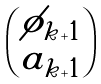<formula> <loc_0><loc_0><loc_500><loc_500>\begin{pmatrix} \phi _ { k + 1 } \\ a _ { k + 1 } \end{pmatrix}</formula> 